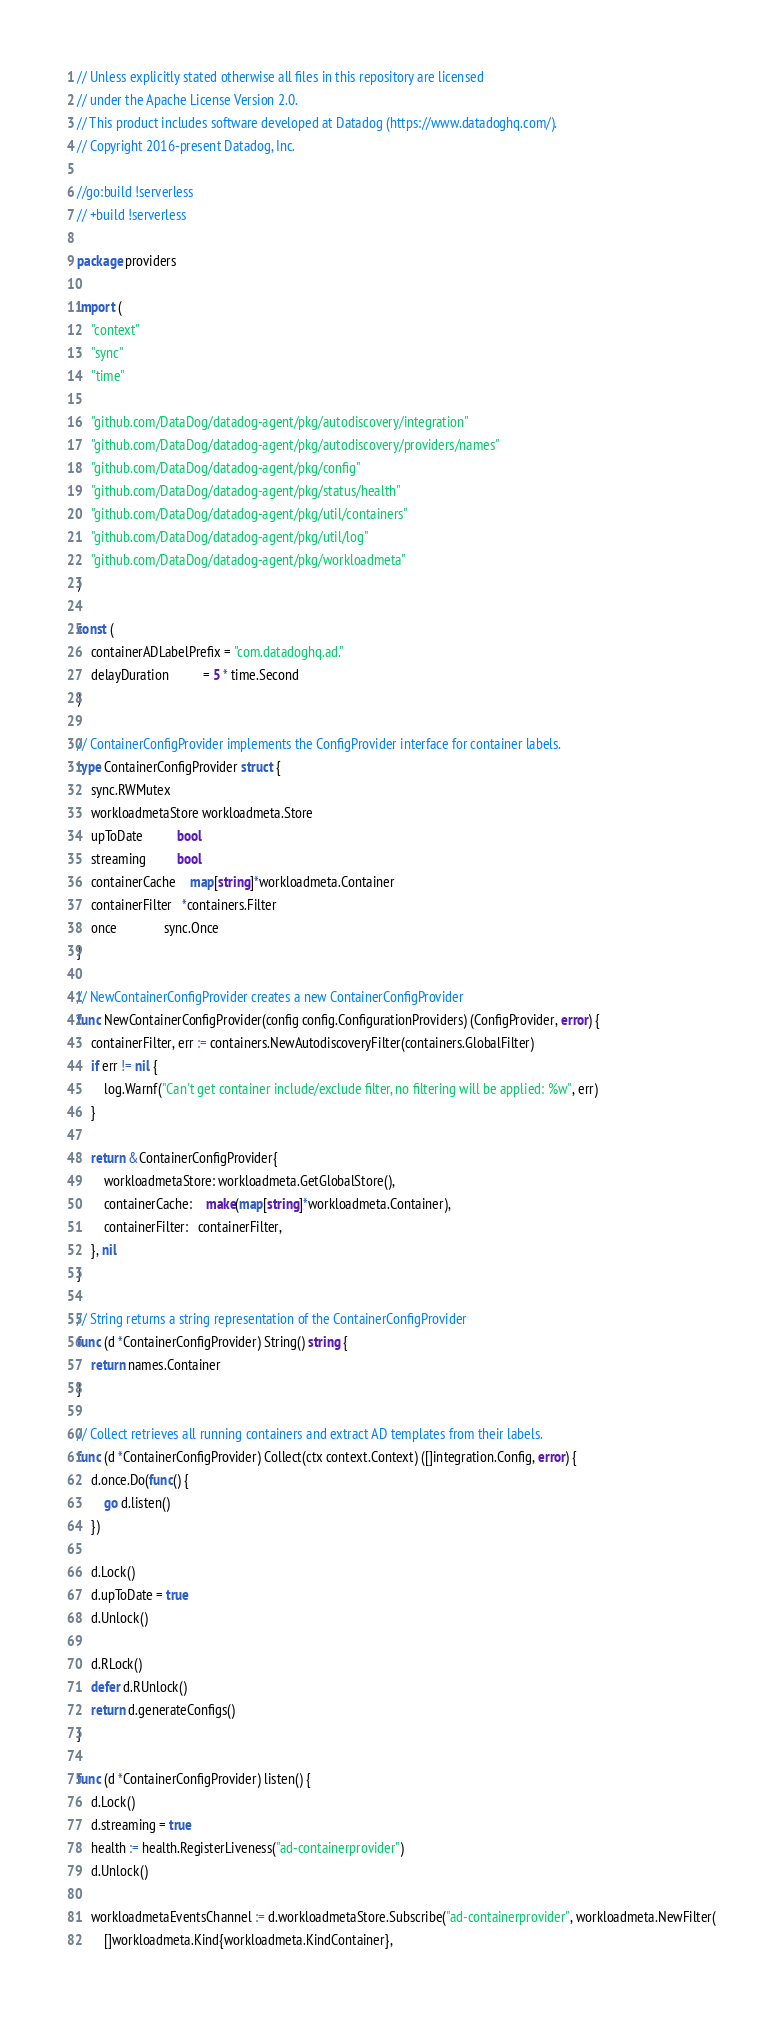Convert code to text. <code><loc_0><loc_0><loc_500><loc_500><_Go_>// Unless explicitly stated otherwise all files in this repository are licensed
// under the Apache License Version 2.0.
// This product includes software developed at Datadog (https://www.datadoghq.com/).
// Copyright 2016-present Datadog, Inc.

//go:build !serverless
// +build !serverless

package providers

import (
	"context"
	"sync"
	"time"

	"github.com/DataDog/datadog-agent/pkg/autodiscovery/integration"
	"github.com/DataDog/datadog-agent/pkg/autodiscovery/providers/names"
	"github.com/DataDog/datadog-agent/pkg/config"
	"github.com/DataDog/datadog-agent/pkg/status/health"
	"github.com/DataDog/datadog-agent/pkg/util/containers"
	"github.com/DataDog/datadog-agent/pkg/util/log"
	"github.com/DataDog/datadog-agent/pkg/workloadmeta"
)

const (
	containerADLabelPrefix = "com.datadoghq.ad."
	delayDuration          = 5 * time.Second
)

// ContainerConfigProvider implements the ConfigProvider interface for container labels.
type ContainerConfigProvider struct {
	sync.RWMutex
	workloadmetaStore workloadmeta.Store
	upToDate          bool
	streaming         bool
	containerCache    map[string]*workloadmeta.Container
	containerFilter   *containers.Filter
	once              sync.Once
}

// NewContainerConfigProvider creates a new ContainerConfigProvider
func NewContainerConfigProvider(config config.ConfigurationProviders) (ConfigProvider, error) {
	containerFilter, err := containers.NewAutodiscoveryFilter(containers.GlobalFilter)
	if err != nil {
		log.Warnf("Can't get container include/exclude filter, no filtering will be applied: %w", err)
	}

	return &ContainerConfigProvider{
		workloadmetaStore: workloadmeta.GetGlobalStore(),
		containerCache:    make(map[string]*workloadmeta.Container),
		containerFilter:   containerFilter,
	}, nil
}

// String returns a string representation of the ContainerConfigProvider
func (d *ContainerConfigProvider) String() string {
	return names.Container
}

// Collect retrieves all running containers and extract AD templates from their labels.
func (d *ContainerConfigProvider) Collect(ctx context.Context) ([]integration.Config, error) {
	d.once.Do(func() {
		go d.listen()
	})

	d.Lock()
	d.upToDate = true
	d.Unlock()

	d.RLock()
	defer d.RUnlock()
	return d.generateConfigs()
}

func (d *ContainerConfigProvider) listen() {
	d.Lock()
	d.streaming = true
	health := health.RegisterLiveness("ad-containerprovider")
	d.Unlock()

	workloadmetaEventsChannel := d.workloadmetaStore.Subscribe("ad-containerprovider", workloadmeta.NewFilter(
		[]workloadmeta.Kind{workloadmeta.KindContainer},</code> 